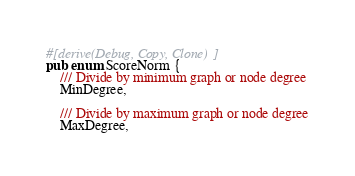Convert code to text. <code><loc_0><loc_0><loc_500><loc_500><_Rust_>#[derive(Debug, Copy, Clone)]
pub enum ScoreNorm {
    /// Divide by minimum graph or node degree
    MinDegree,

    /// Divide by maximum graph or node degree
    MaxDegree,</code> 